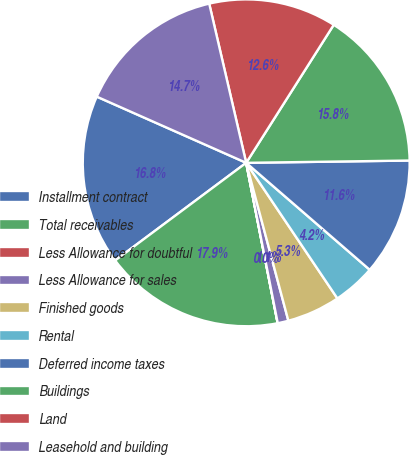<chart> <loc_0><loc_0><loc_500><loc_500><pie_chart><fcel>Installment contract<fcel>Total receivables<fcel>Less Allowance for doubtful<fcel>Less Allowance for sales<fcel>Finished goods<fcel>Rental<fcel>Deferred income taxes<fcel>Buildings<fcel>Land<fcel>Leasehold and building<nl><fcel>16.83%<fcel>17.89%<fcel>0.01%<fcel>1.06%<fcel>5.27%<fcel>4.22%<fcel>11.58%<fcel>15.78%<fcel>12.63%<fcel>14.73%<nl></chart> 